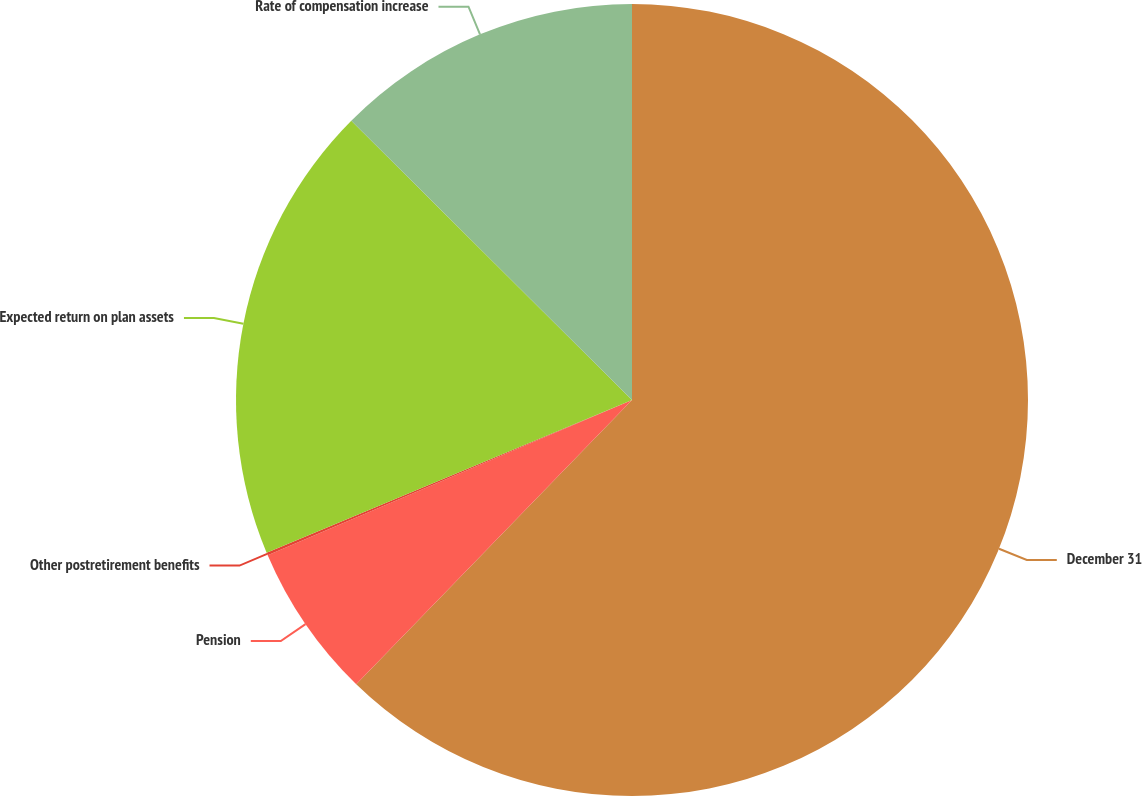Convert chart. <chart><loc_0><loc_0><loc_500><loc_500><pie_chart><fcel>December 31<fcel>Pension<fcel>Other postretirement benefits<fcel>Expected return on plan assets<fcel>Rate of compensation increase<nl><fcel>62.26%<fcel>6.33%<fcel>0.11%<fcel>18.76%<fcel>12.54%<nl></chart> 